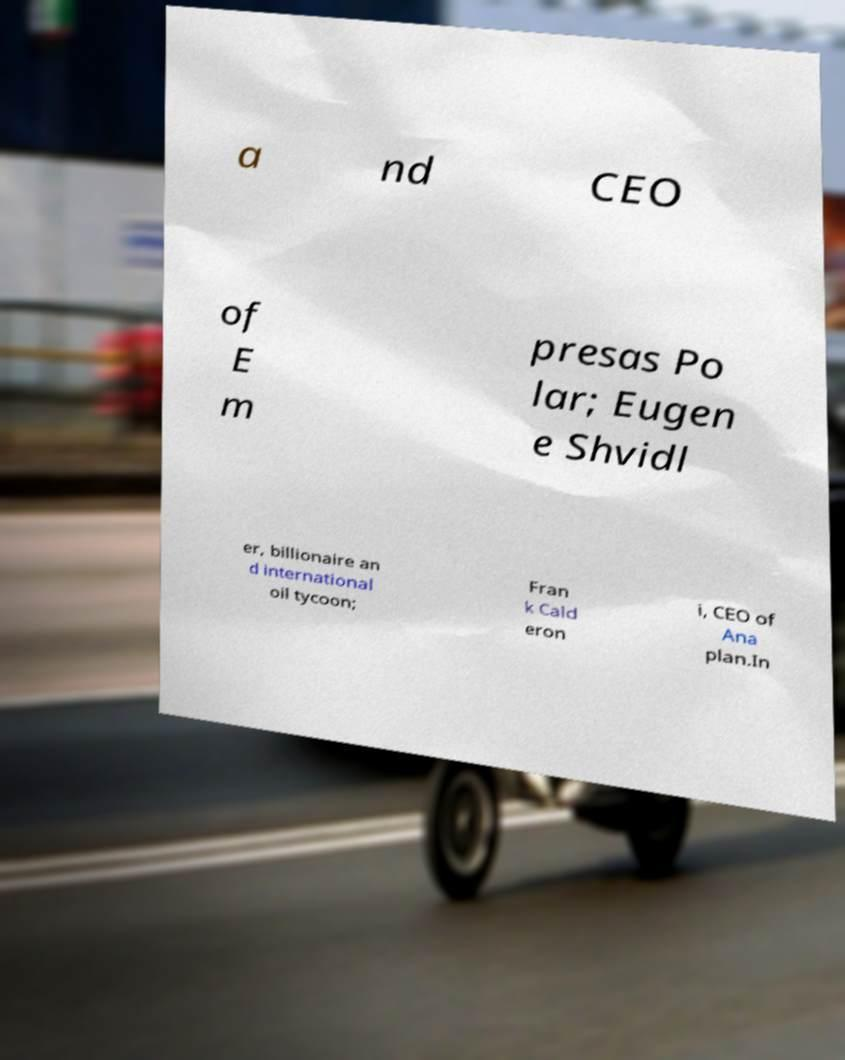I need the written content from this picture converted into text. Can you do that? a nd CEO of E m presas Po lar; Eugen e Shvidl er, billionaire an d international oil tycoon; Fran k Cald eron i, CEO of Ana plan.In 